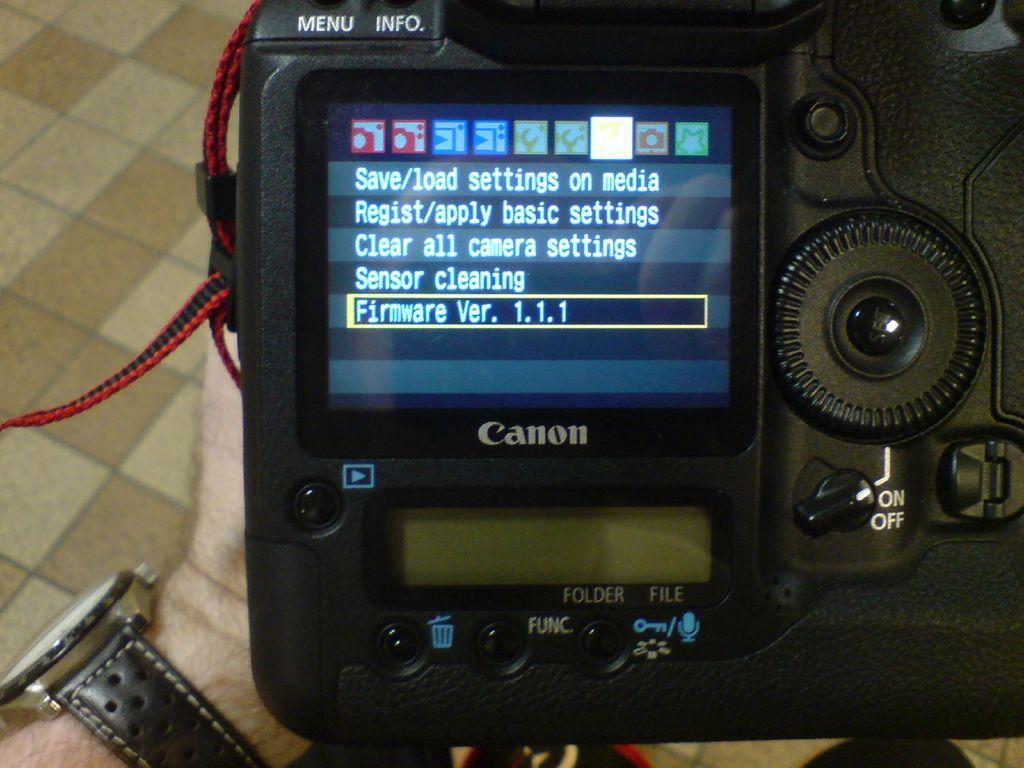Provide a one-sentence caption for the provided image. A man holding a camera revealing that it is using firmware version 1.1.1. 